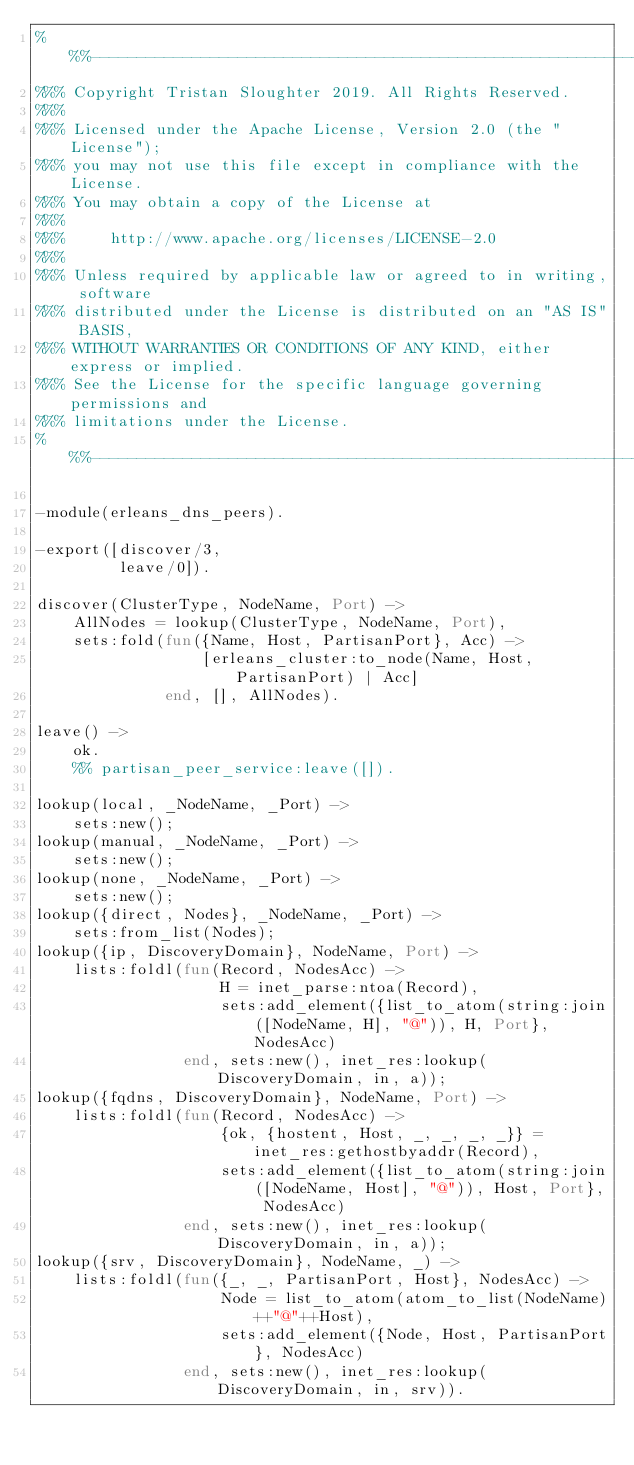<code> <loc_0><loc_0><loc_500><loc_500><_Erlang_>%%%----------------------------------------------------------------------------
%%% Copyright Tristan Sloughter 2019. All Rights Reserved.
%%%
%%% Licensed under the Apache License, Version 2.0 (the "License");
%%% you may not use this file except in compliance with the License.
%%% You may obtain a copy of the License at
%%%
%%%     http://www.apache.org/licenses/LICENSE-2.0
%%%
%%% Unless required by applicable law or agreed to in writing, software
%%% distributed under the License is distributed on an "AS IS" BASIS,
%%% WITHOUT WARRANTIES OR CONDITIONS OF ANY KIND, either express or implied.
%%% See the License for the specific language governing permissions and
%%% limitations under the License.
%%%----------------------------------------------------------------------------

-module(erleans_dns_peers).

-export([discover/3,
         leave/0]).

discover(ClusterType, NodeName, Port) ->
    AllNodes = lookup(ClusterType, NodeName, Port),
    sets:fold(fun({Name, Host, PartisanPort}, Acc) ->
                  [erleans_cluster:to_node(Name, Host, PartisanPort) | Acc]
              end, [], AllNodes).

leave() ->
    ok.
    %% partisan_peer_service:leave([]).

lookup(local, _NodeName, _Port) ->
    sets:new();
lookup(manual, _NodeName, _Port) ->
    sets:new();
lookup(none, _NodeName, _Port) ->
    sets:new();
lookup({direct, Nodes}, _NodeName, _Port) ->
    sets:from_list(Nodes);
lookup({ip, DiscoveryDomain}, NodeName, Port) ->
    lists:foldl(fun(Record, NodesAcc) ->
                    H = inet_parse:ntoa(Record),
                    sets:add_element({list_to_atom(string:join([NodeName, H], "@")), H, Port}, NodesAcc)
                end, sets:new(), inet_res:lookup(DiscoveryDomain, in, a));
lookup({fqdns, DiscoveryDomain}, NodeName, Port) ->
    lists:foldl(fun(Record, NodesAcc) ->
                    {ok, {hostent, Host, _, _, _, _}} = inet_res:gethostbyaddr(Record),
                    sets:add_element({list_to_atom(string:join([NodeName, Host], "@")), Host, Port}, NodesAcc)
                end, sets:new(), inet_res:lookup(DiscoveryDomain, in, a));
lookup({srv, DiscoveryDomain}, NodeName, _) ->
    lists:foldl(fun({_, _, PartisanPort, Host}, NodesAcc) ->
                    Node = list_to_atom(atom_to_list(NodeName)++"@"++Host),
                    sets:add_element({Node, Host, PartisanPort}, NodesAcc)
                end, sets:new(), inet_res:lookup(DiscoveryDomain, in, srv)).
</code> 